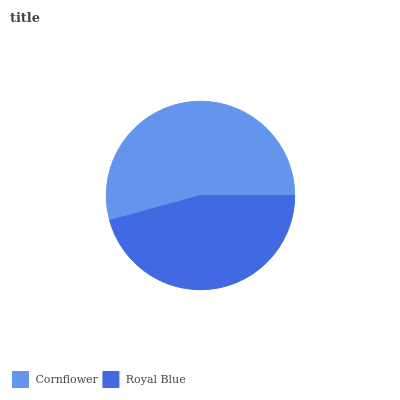Is Royal Blue the minimum?
Answer yes or no. Yes. Is Cornflower the maximum?
Answer yes or no. Yes. Is Royal Blue the maximum?
Answer yes or no. No. Is Cornflower greater than Royal Blue?
Answer yes or no. Yes. Is Royal Blue less than Cornflower?
Answer yes or no. Yes. Is Royal Blue greater than Cornflower?
Answer yes or no. No. Is Cornflower less than Royal Blue?
Answer yes or no. No. Is Cornflower the high median?
Answer yes or no. Yes. Is Royal Blue the low median?
Answer yes or no. Yes. Is Royal Blue the high median?
Answer yes or no. No. Is Cornflower the low median?
Answer yes or no. No. 